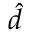<formula> <loc_0><loc_0><loc_500><loc_500>\hat { d }</formula> 